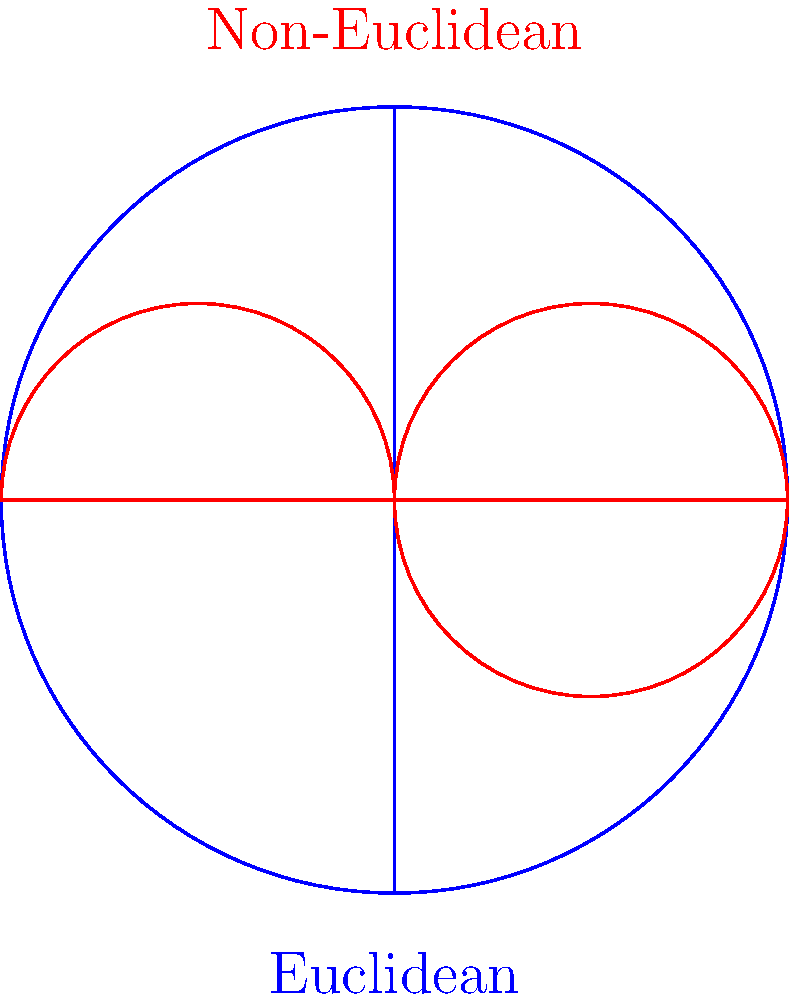In the context of media influence on public opinion, how might the differences between Euclidean and non-Euclidean geometries, as shown in the image, be used as a metaphor to explain the concept of "filter bubbles" in social media algorithms? To answer this question, let's break down the concept of "filter bubbles" and relate it to the geometric representations:

1. Euclidean geometry (blue):
   - Represents a "flat" space where parallel lines never intersect.
   - In media terms, this could represent a traditional, broad-based media landscape where information flows linearly and reaches a wide audience.

2. Non-Euclidean geometry (red):
   - Shows curved lines and distorted spaces.
   - This can represent the curvature of information flow in social media algorithms.

3. Filter bubbles in social media:
   - Algorithms create personalized content feeds based on user preferences and behavior.
   - This creates a "curved" information space where users are more likely to encounter content that aligns with their existing views.

4. Metaphorical comparison:
   - Euclidean space: Information travels in straight lines, reaching diverse audiences.
   - Non-Euclidean space: Information travels along curved paths, creating isolated bubbles of like-minded individuals.

5. Impact on public opinion:
   - In the Euclidean model, diverse viewpoints are more likely to intersect.
   - In the non-Euclidean model, viewpoints may become increasingly isolated and polarized.

6. Strategic implications:
   - Political strategists must understand how these "curved" information spaces affect message dissemination and public opinion formation.
   - Strategies may need to be adapted to penetrate or leverage these filter bubbles effectively.

The metaphor illustrates how social media algorithms can create distorted information landscapes, similar to how non-Euclidean geometry distorts space, potentially leading to fragmented and polarized public opinions.
Answer: Filter bubbles distort information flow like non-Euclidean geometry distorts space, creating isolated opinion spheres. 